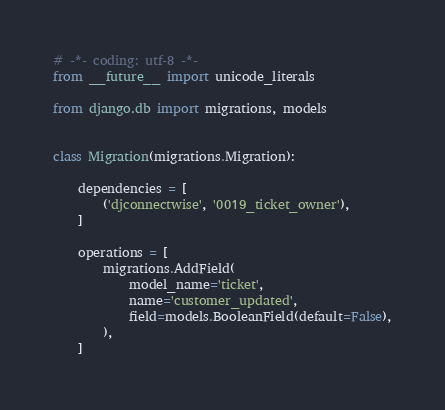<code> <loc_0><loc_0><loc_500><loc_500><_Python_># -*- coding: utf-8 -*-
from __future__ import unicode_literals

from django.db import migrations, models


class Migration(migrations.Migration):

    dependencies = [
        ('djconnectwise', '0019_ticket_owner'),
    ]

    operations = [
        migrations.AddField(
            model_name='ticket',
            name='customer_updated',
            field=models.BooleanField(default=False),
        ),
    ]
</code> 